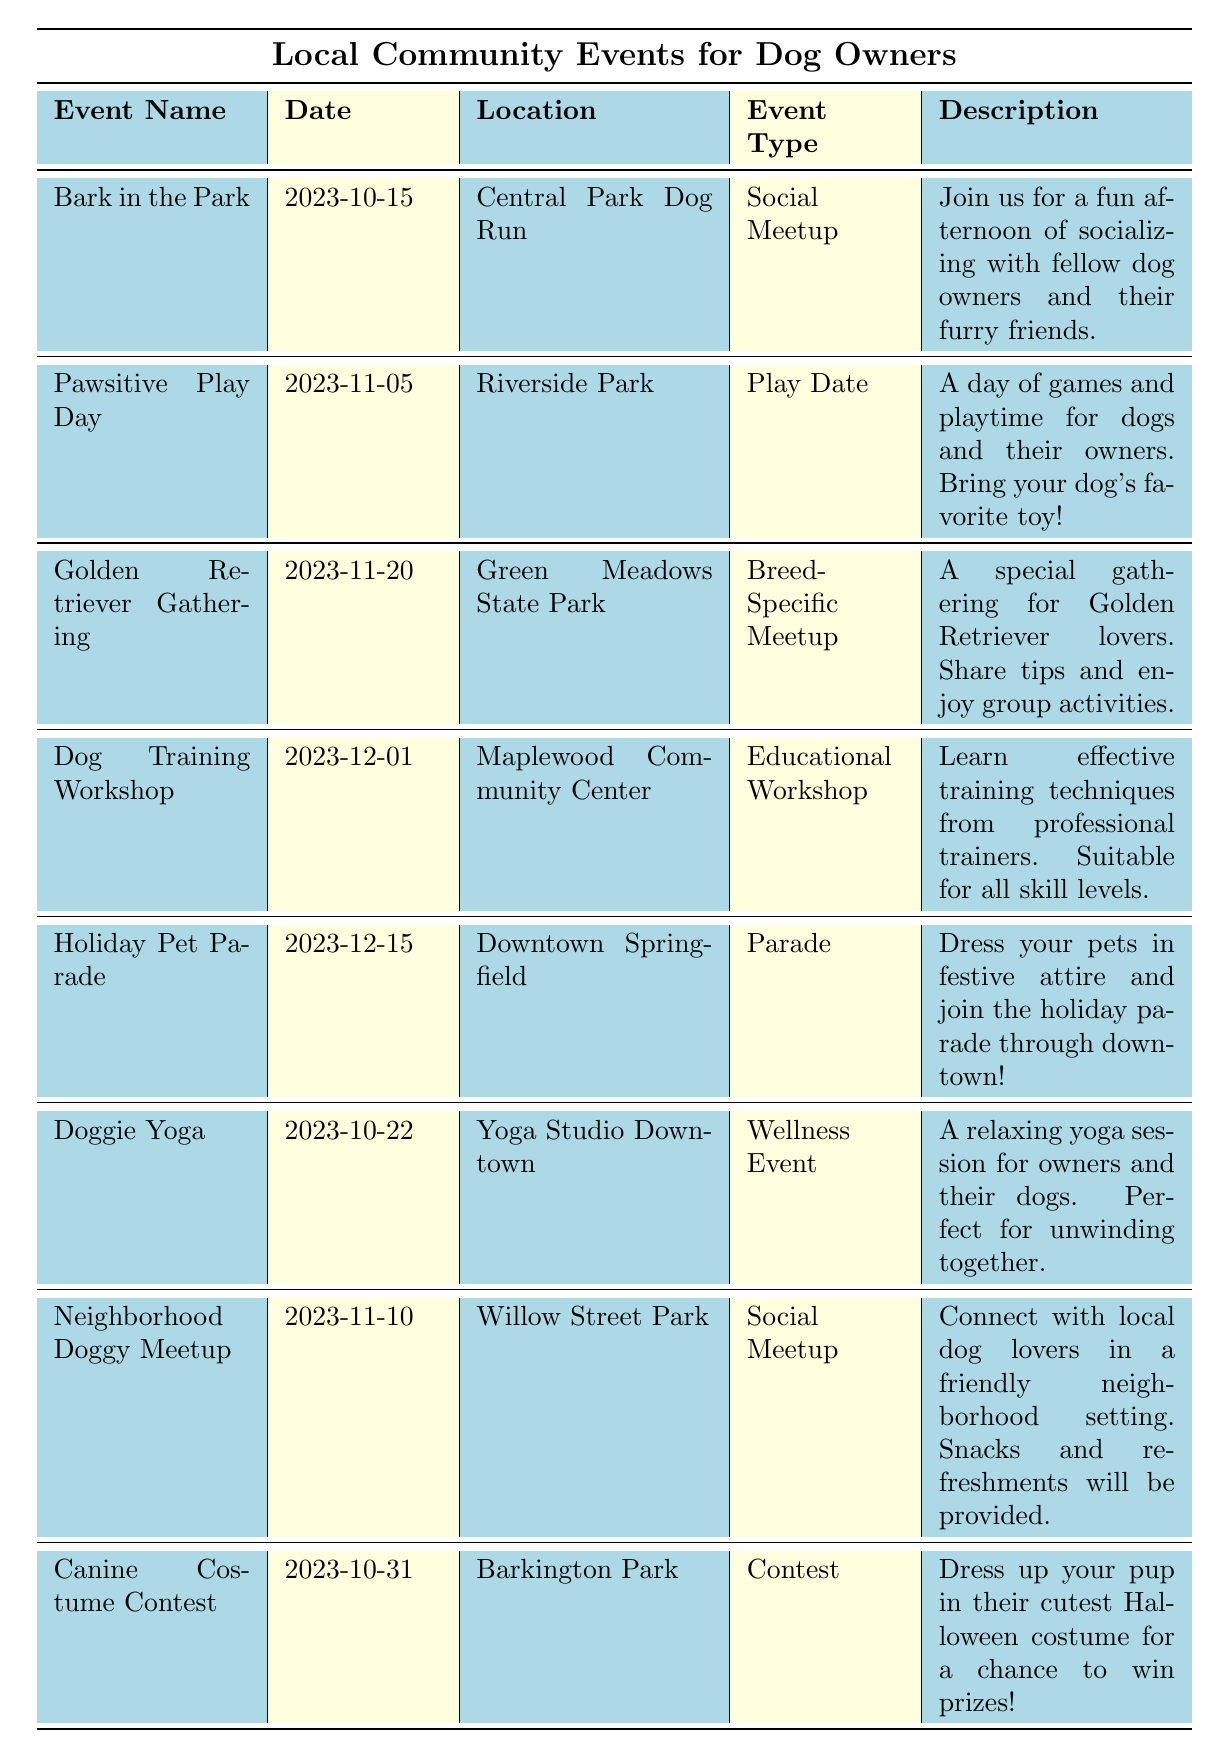What is the date of the "Dog Training Workshop"? The table lists the events under the "Date" column. By locating "Dog Training Workshop" in the "Event Name" column, we see that the corresponding date is "2023-12-01".
Answer: 2023-12-01 How many events are scheduled for the month of October? The table displays events, and the "Date" column shows the dates for each event. By checking October, there are two events listed: "Bark in the Park" on "2023-10-15" and "Doggie Yoga" on "2023-10-22", making a total of two events.
Answer: 2 Which event takes place in Riverside Park? By observing the "Location" column, the event "Pawsitive Play Day" is noted to occur in Riverside Park.
Answer: Pawsitive Play Day Is the "Golden Retriever Gathering" a breed-specific meetup? The table describes the "Golden Retriever Gathering" under the "Event Type" column and confirms it is categorized as a "Breed-Specific Meetup".
Answer: Yes What are the common age groups included in the events? By reviewing the "Age Group" information of each event, we see multiple instances of "All Ages". The only event specifically for "Adults" is the "Dog Training Workshop" and "Doggie Yoga". Thus, "All Ages" is common across most events.
Answer: All Ages What is the newest event listed in the table? To find the newest event, we compare the dates in the "Date" column. The event "Holiday Pet Parade" on "2023-12-15" has the latest date among all the entries.
Answer: Holiday Pet Parade How many events take place after November 10th? By examining the dates listed, we identify events after November 10th. They include "Golden Retriever Gathering" on "2023-11-20", "Dog Training Workshop" on "2023-12-01", and "Holiday Pet Parade" on "2023-12-15". This results in three events.
Answer: 3 Which event has a wellness theme? The "Event Type" column categorizes "Doggie Yoga" under "Wellness Event", indicating that it has a wellness theme.
Answer: Doggie Yoga How many events are held in parks compared to community centers? By looking at the locations, the events in parks are: "Bark in the Park", "Pawsitive Play Day", "Golden Retriever Gathering", "Neighborhood Doggy Meetup", "Canine Costume Contest", totaling five events. The community center hosts "Dog Training Workshop". Thus, 5 events are in parks, and 1 in a community center.
Answer: Parks: 5, Community Centers: 1 What type of event is the "Canine Costume Contest"? The table categorizes the "Canine Costume Contest" in the "Event Type" column as a "Contest", explicitly stating the type of event.
Answer: Contest 